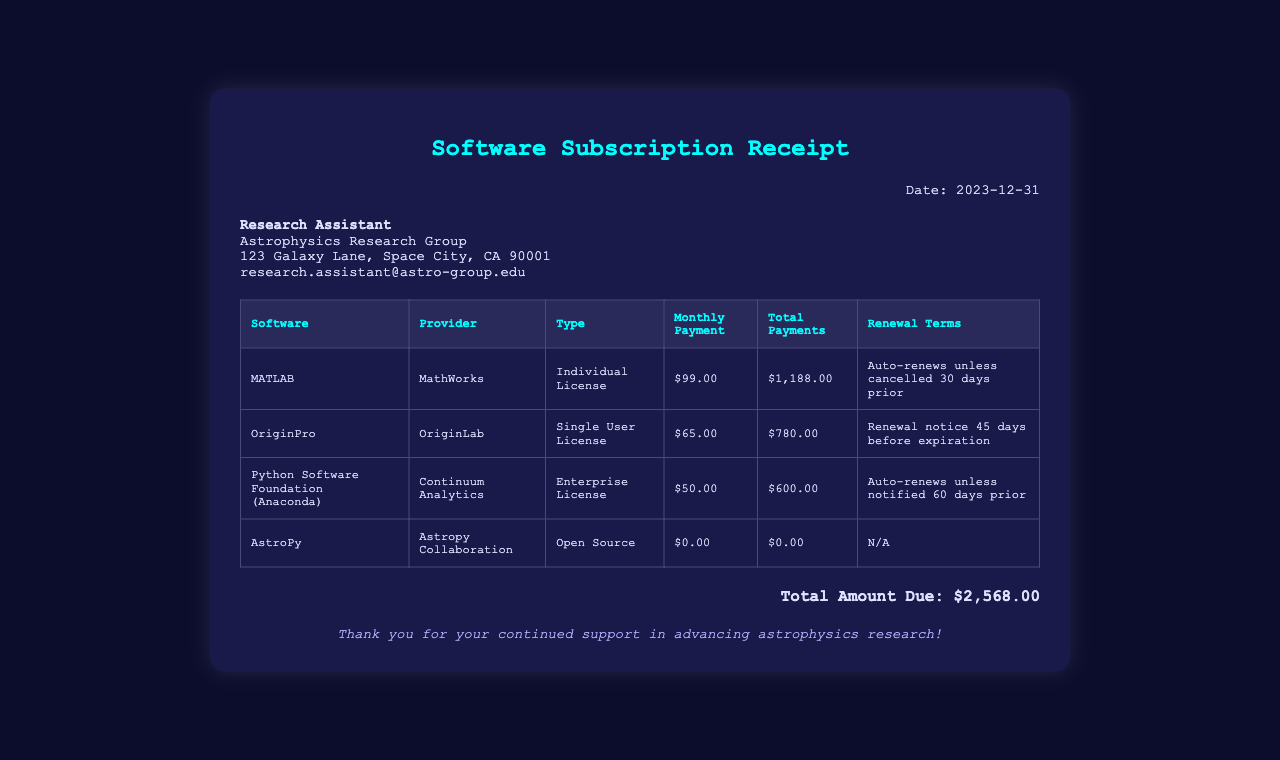What is the date of the receipt? The date of the receipt is clearly stated at the top of the document.
Answer: 2023-12-31 What is the total amount due? The total amount due is listed at the bottom of the receipt.
Answer: $2,568.00 Who is the provider of the MATLAB software? The provider of MATLAB is mentioned in the second column of the associated table.
Answer: MathWorks What is the monthly payment for OriginPro? The monthly payment for OriginPro is specified in the table under the "Monthly Payment" column.
Answer: $65.00 How many days before automatic renewal should MATLAB be canceled? The renewal terms for MATLAB specify the cancellation period before renewal.
Answer: 30 days What type of license is associated with Python Software Foundation? The license type for Python Software Foundation is indicated in the "Type" column of the table.
Answer: Enterprise License Is AstroPy a paid software? The total payments for AstroPy are given as $0.00 in the table, indicating if it's paid or free software.
Answer: $0.00 What is the total payment for the OriginPro software? The total payments for OriginPro are shown in the table, providing the fixed payment amount.
Answer: $780.00 What is the renewal notice period for OriginPro? Renewal terms for OriginPro describe how long before expiration a renewal notice is given.
Answer: 45 days before expiration 